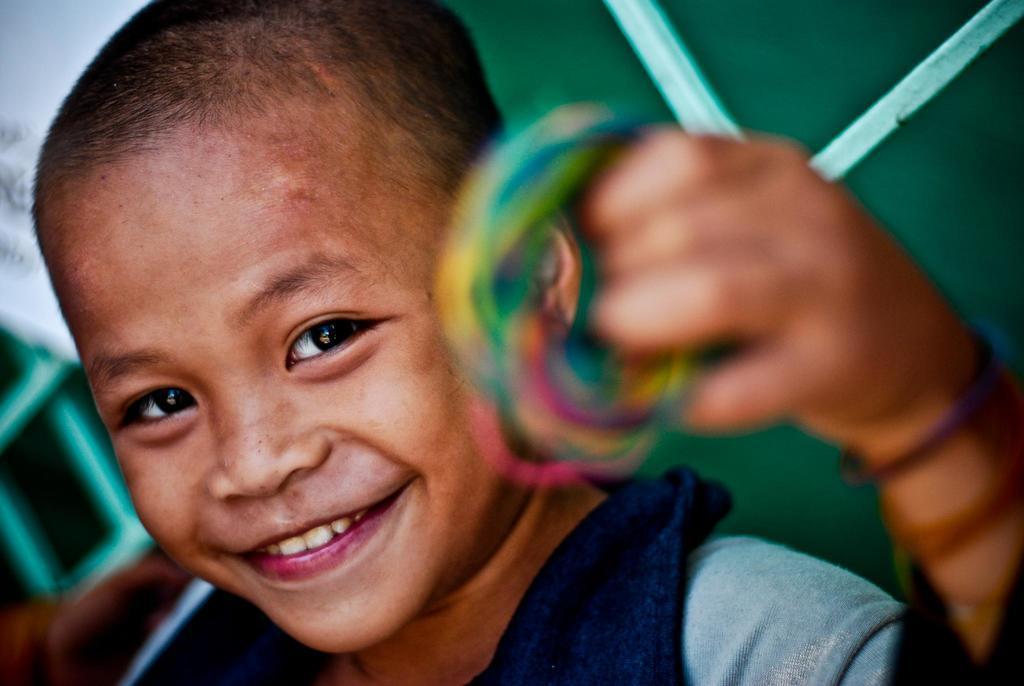How would you summarize this image in a sentence or two? In this picture I can see a boy holding something in his hand and looks like a metal grill in the background. 